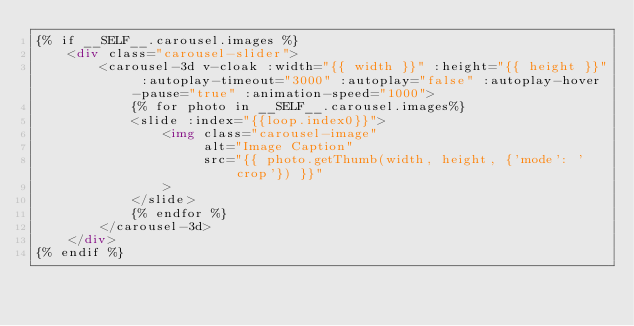<code> <loc_0><loc_0><loc_500><loc_500><_HTML_>{% if __SELF__.carousel.images %}
    <div class="carousel-slider">
        <carousel-3d v-cloak :width="{{ width }}" :height="{{ height }}" :autoplay-timeout="3000" :autoplay="false" :autoplay-hover-pause="true" :animation-speed="1000">
            {% for photo in __SELF__.carousel.images%}
            <slide :index="{{loop.index0}}">
                <img class="carousel-image"
                     alt="Image Caption"
                     src="{{ photo.getThumb(width, height, {'mode': 'crop'}) }}"
                >
            </slide>
            {% endfor %}
        </carousel-3d>
    </div>
{% endif %}
</code> 